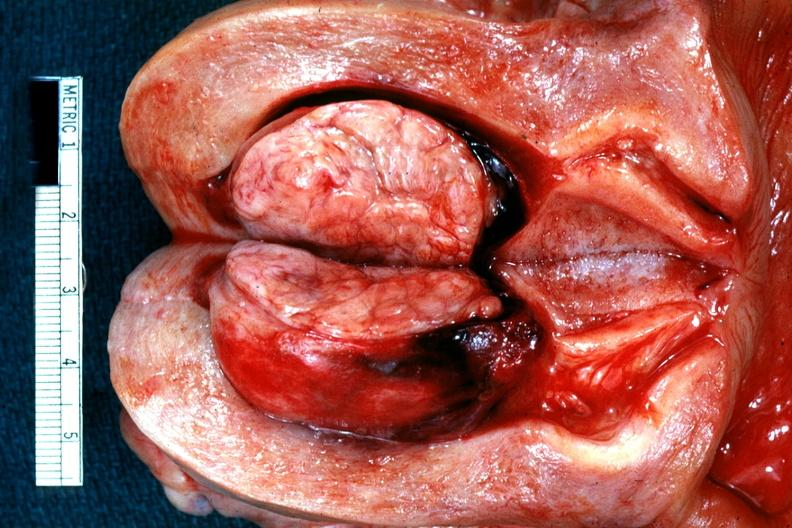s female reproductive present?
Answer the question using a single word or phrase. Yes 